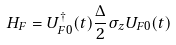<formula> <loc_0><loc_0><loc_500><loc_500>H _ { F } = U _ { F 0 } ^ { \dagger } ( t ) \frac { \Delta } { 2 } \sigma _ { z } U _ { F 0 } ( t )</formula> 